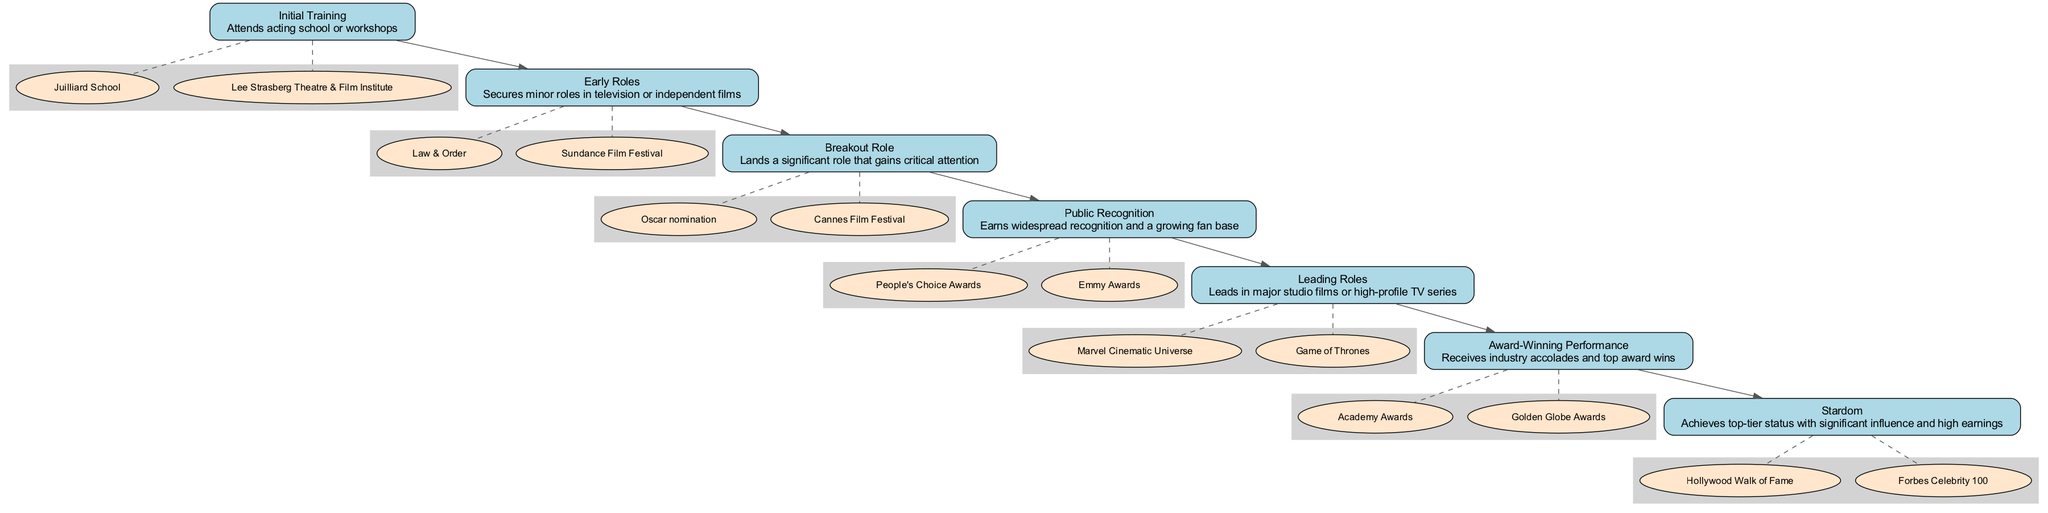What is the first stage in the pathway? The first stage in the diagram is 'Initial Training', as it is positioned at the top of the flow. This is clarified by looking for the first node in the sequence indicating the start of the actor's career journey.
Answer: Initial Training How many entities are associated with the 'Breakout Role' stage? The 'Breakout Role' stage has two entities linked to it, which can be identified by counting the nodes under the 'Breakout Role' cluster that mention specific recognitions like 'Oscar nomination' and 'Cannes Film Festival'.
Answer: 2 What significant recognition is achieved at the 'Award-Winning Performance' stage? At this stage, the significant recognitions are 'Academy Awards' and 'Golden Globe Awards'. By reviewing the entities in the 'Award-Winning Performance' section, these two awards represent the pinnacle of industry accolades for an actor.
Answer: Academy Awards, Golden Globe Awards What is the last stage in the pathway? The last stage in the pathway is 'Stardom', clearly indicated as the final node at the bottom of the flow, signifying the culmination of the actor's career journey.
Answer: Stardom Which stage comes after 'Public Recognition'? The stage that follows 'Public Recognition' in the pathway is 'Leading Roles'. This is determined by tracing the sequence of stages from one node to the next in the diagram.
Answer: Leading Roles What type of roles does an actor secure in the 'Early Roles' stage? In the 'Early Roles' stage, actors typically secure minor roles in television or independent films. This is identified by looking at the description associated with the 'Early Roles' node.
Answer: Minor roles How many total stages are depicted in the pathway? The total number of stages in the pathway is seven. This can be confirmed by counting each individual stage node throughout the diagram.
Answer: 7 What entities are associated with 'Leading Roles'? The entities associated with 'Leading Roles' include 'Marvel Cinematic Universe' and 'Game of Thrones'. These can be identified by reviewing the entities listed under the 'Leading Roles' stage.
Answer: Marvel Cinematic Universe, Game of Thrones What does 'Stardom' signify in the pathway? 'Stardom' signifies achieving top-tier status with significant influence and high earnings. This is derived from the description provided in the 'Stardom' stage of the pathway, illustrating the peak of a leading actor's career.
Answer: Top-tier status 